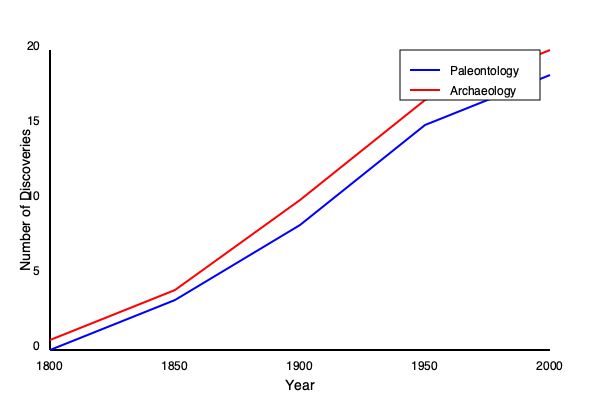Based on the graph showing the number of significant discoveries in paleontology and archaeology over time, what can be inferred about the relationship between these two fields in terms of their discovery rates from 1800 to 2000? To answer this question, we need to analyze the trends shown in the graph for both paleontology and archaeology:

1. Starting points:
   - In 1800, both fields had very few significant discoveries (close to 0).

2. Growth patterns:
   - Both fields show an increase in discoveries over time.
   - The lines for both disciplines follow a similar upward trajectory.

3. Comparison of slopes:
   - The slopes of both lines are relatively similar, indicating comparable rates of increase in discoveries.
   - Archaeology (red line) shows a slightly steeper slope, especially after 1900.

4. End points:
   - By 2000, archaeology has a higher number of significant discoveries compared to paleontology.

5. Interdisciplinary implications:
   - The similar growth patterns suggest that advancements in one field might have influenced the other.
   - Technological or methodological improvements likely benefited both disciplines simultaneously.

6. Relative growth:
   - Archaeology shows a marginally faster growth rate, especially in the latter half of the 20th century.
   - This could be due to factors such as increased funding, public interest, or the accessibility of archaeological sites compared to paleontological ones.

Given these observations, we can infer that paleontology and archaeology experienced parallel growth in significant discoveries from 1800 to 2000, with archaeology showing a slightly higher rate of discovery, especially in the 20th century. This parallel growth suggests a strong interdisciplinary connection between the two fields, likely due to shared methodologies, technologies, and scientific advancements.
Answer: Parallel growth with archaeology slightly outpacing paleontology, indicating strong interdisciplinary connections. 